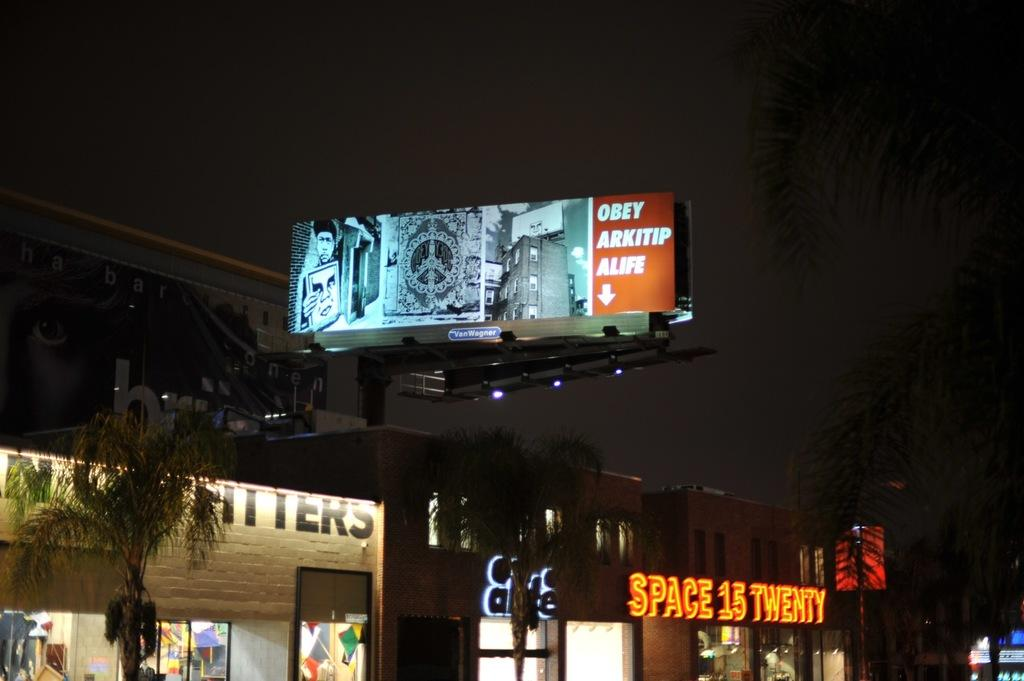<image>
Describe the image concisely. A cryptic billboard advertising obeying alipe sits above a street. 